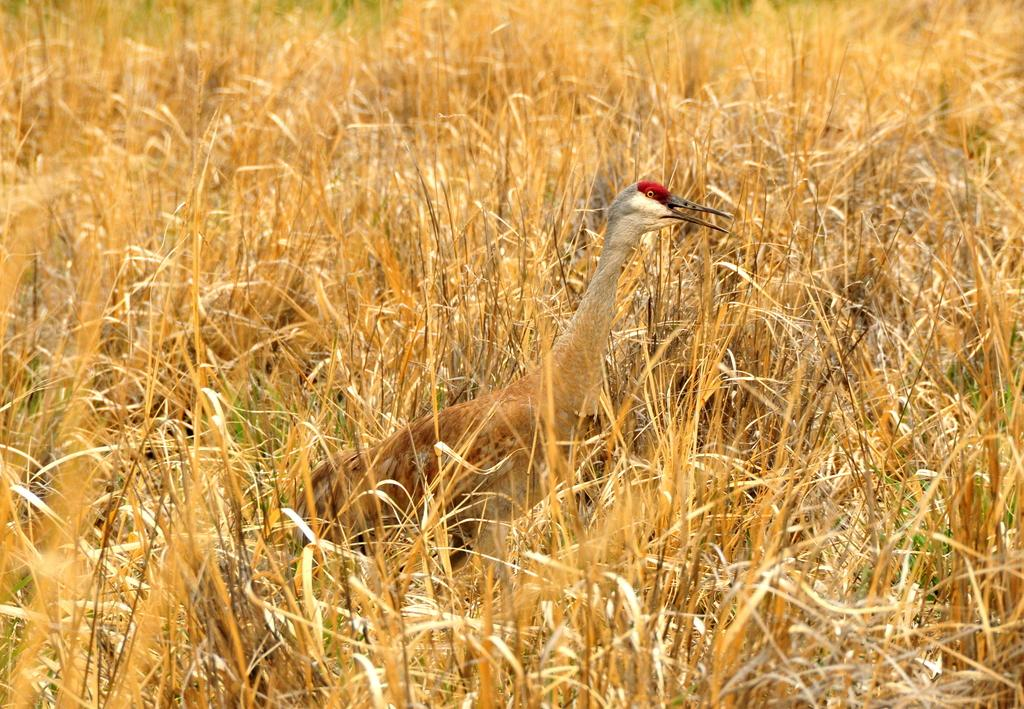What type of animal can be seen in the image? There is a bird in the image. What can be seen in the background of the image? There is grass visible in the background of the image. How many dinosaurs are present in the image? There are no dinosaurs present in the image; it features a bird and grass. What historical event is depicted in the image? There is no historical event depicted in the image; it features a bird and grass. 